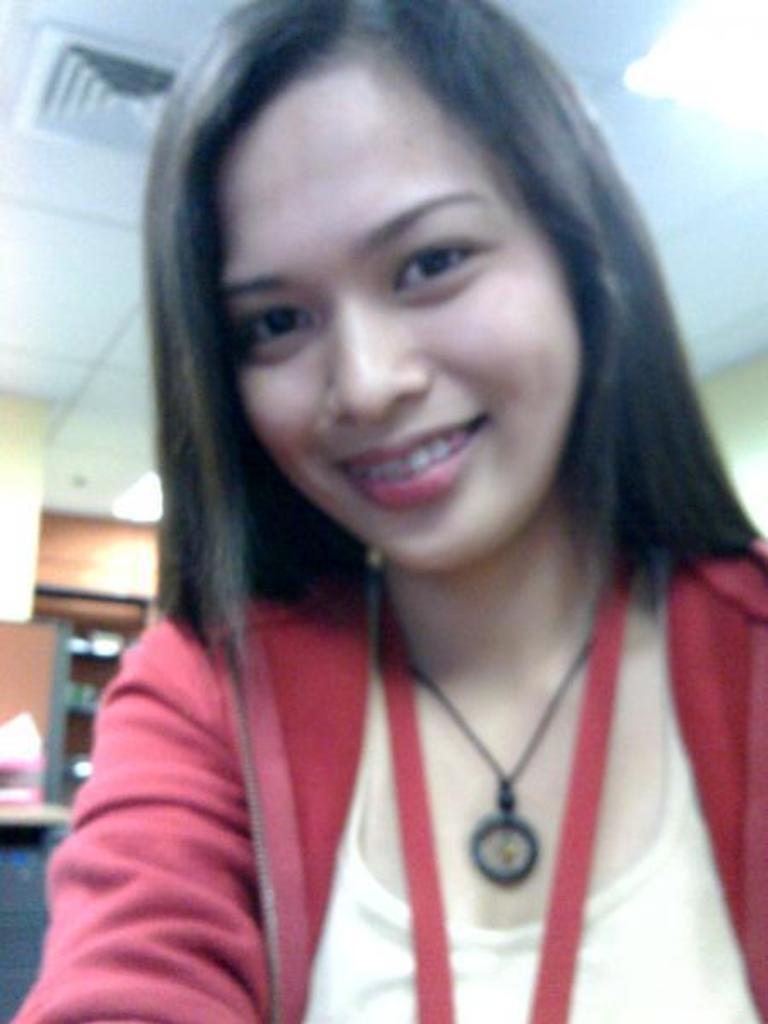Who is present in the image? There is a woman in the image. What can be seen in the background of the image? There are lights on the ceiling, objects on the racks, and objects on the wall in the background of the image. Can you describe the snail crawling on the roof in the image? There is no snail or roof present in the image. 